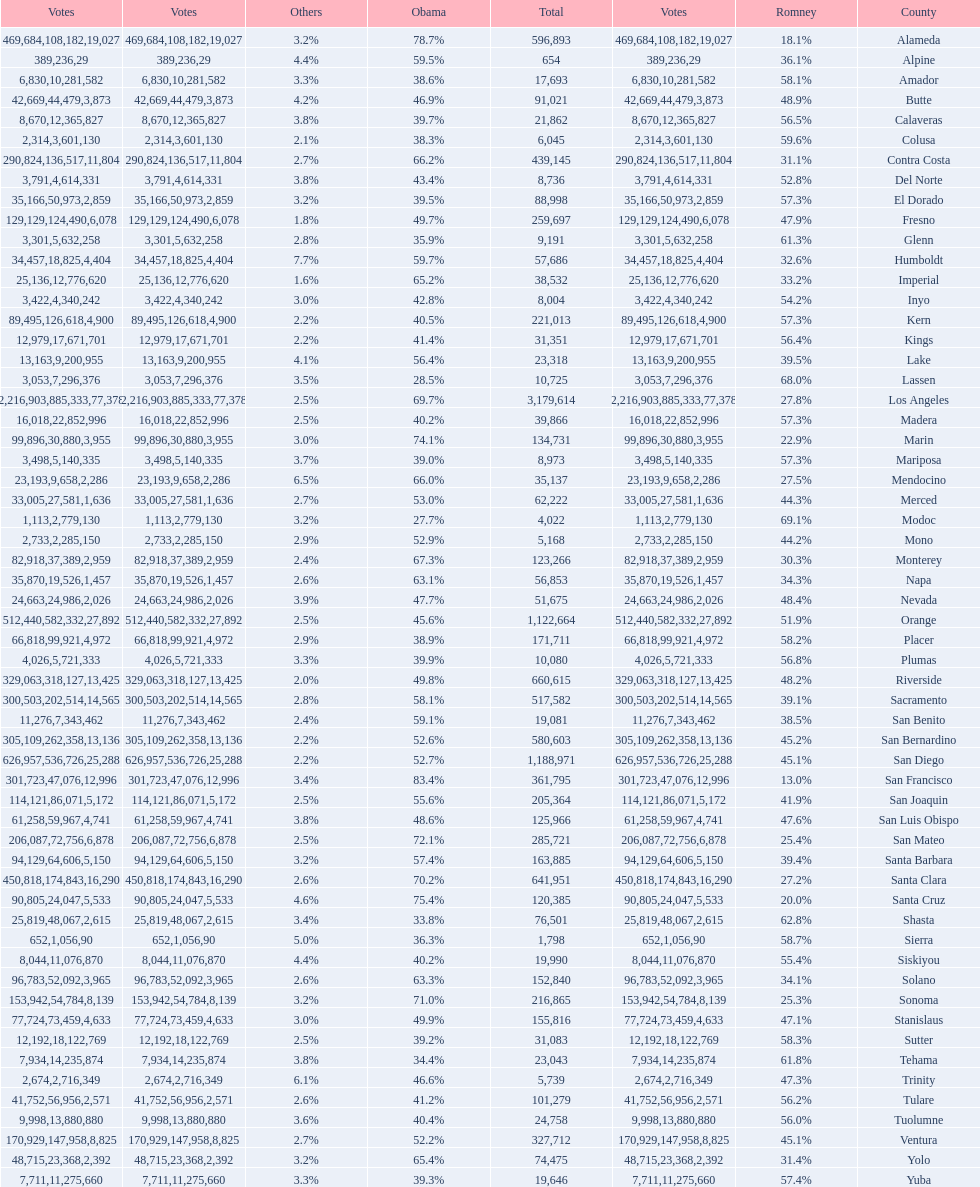Which county had the lower percentage votes for obama: amador, humboldt, or lake? Amador. 